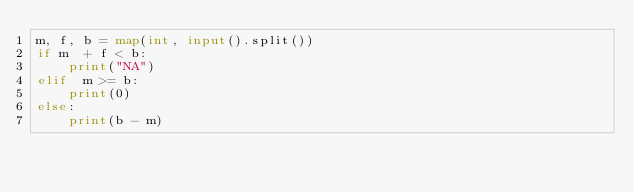<code> <loc_0><loc_0><loc_500><loc_500><_Python_>m, f, b = map(int, input().split())
if m  + f < b:
    print("NA")
elif  m >= b:
    print(0)
else:
    print(b - m)

</code> 